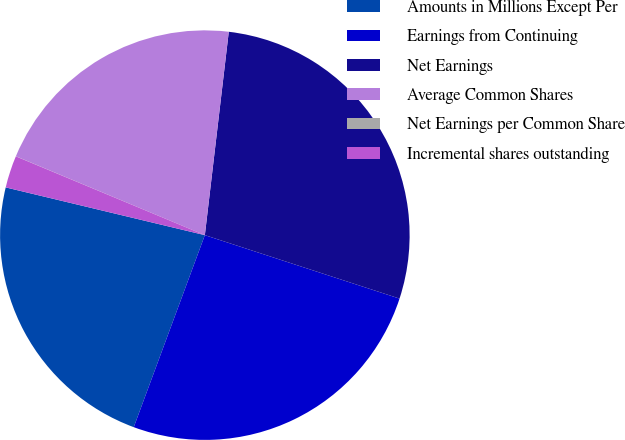<chart> <loc_0><loc_0><loc_500><loc_500><pie_chart><fcel>Amounts in Millions Except Per<fcel>Earnings from Continuing<fcel>Net Earnings<fcel>Average Common Shares<fcel>Net Earnings per Common Share<fcel>Incremental shares outstanding<nl><fcel>23.1%<fcel>25.63%<fcel>28.15%<fcel>20.57%<fcel>0.01%<fcel>2.54%<nl></chart> 